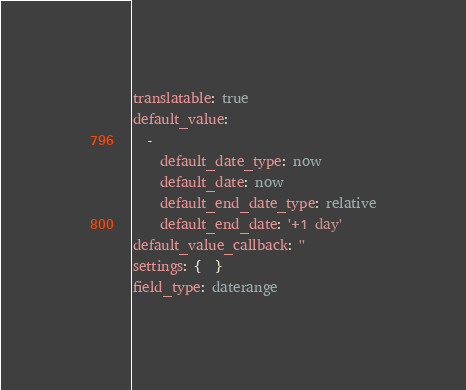<code> <loc_0><loc_0><loc_500><loc_500><_YAML_>translatable: true
default_value:
  -
    default_date_type: now
    default_date: now
    default_end_date_type: relative
    default_end_date: '+1 day'
default_value_callback: ''
settings: {  }
field_type: daterange
</code> 